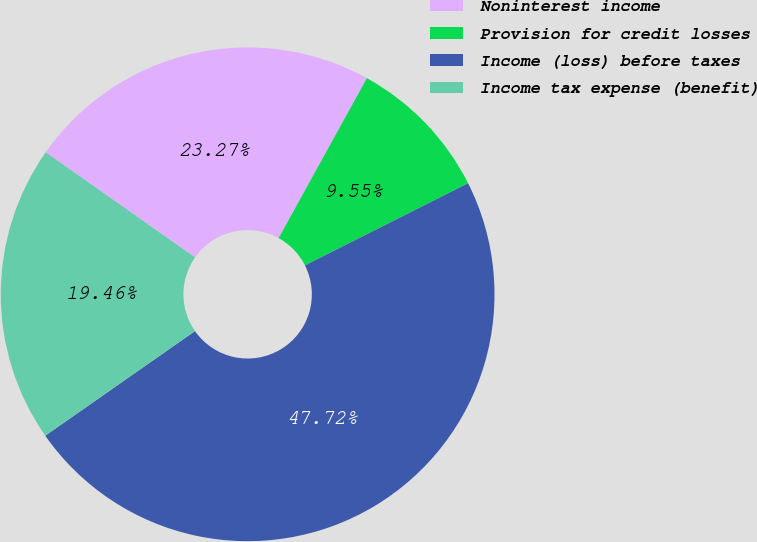Convert chart. <chart><loc_0><loc_0><loc_500><loc_500><pie_chart><fcel>Noninterest income<fcel>Provision for credit losses<fcel>Income (loss) before taxes<fcel>Income tax expense (benefit)<nl><fcel>23.27%<fcel>9.55%<fcel>47.72%<fcel>19.46%<nl></chart> 